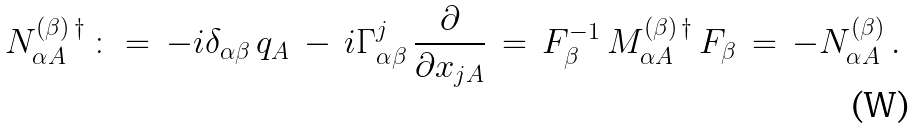Convert formula to latex. <formula><loc_0><loc_0><loc_500><loc_500>N ^ { ( \beta ) \, \dagger } _ { \alpha A } \, \colon = \, - i \delta _ { \alpha \beta } \, q _ { A } \, - \, i \Gamma ^ { j } _ { \alpha \beta } \, \frac { \partial } { \partial x _ { j A } } \, = \, F _ { \beta } ^ { - 1 } \, M ^ { ( \beta ) \, \dagger } _ { \alpha A } \, F _ { \beta } \, = \, - N _ { \alpha A } ^ { ( \beta ) } \, .</formula> 